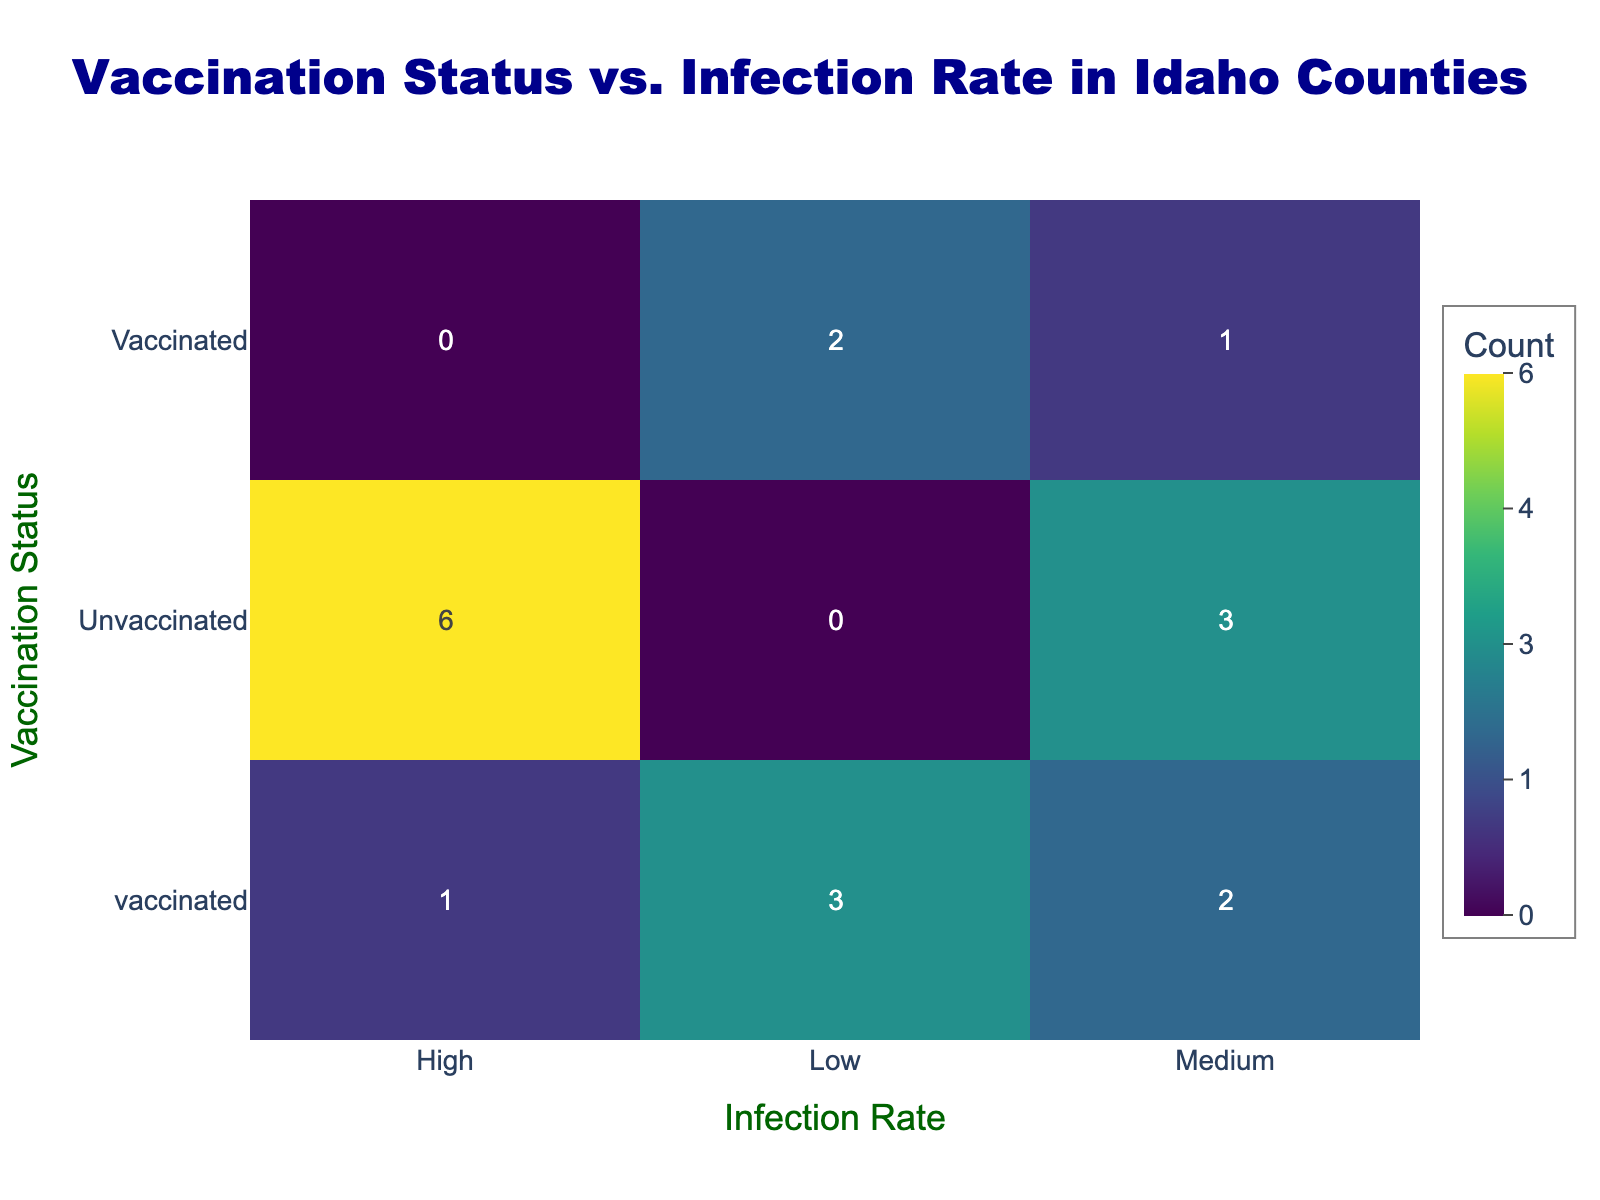What is the infection rate for vaccinated individuals in Ada County? In the table, the row for Ada County under the "Vaccinated" category shows an infection rate of "Low". Therefore, the answer is based directly on this single observation.
Answer: Low How many counties have vaccinated individuals with a medium infection rate? The counties with vaccinated individuals and a medium infection rate are Canyon and Latah. Therefore, counting these entries gives us 2 counties.
Answer: 2 Is it true that Bannock County has unvaccinated individuals with a low infection rate? Looking at the data for Bannock County, the row for unvaccinated individuals shows an infection rate of "High", so this statement is false.
Answer: No What is the total count of unvaccinated individuals across all counties represented in the table? To find the total, we count the unvaccinated entries: Ada (1), Canyon (1), Bonner (1), Bannock (1), Bingham (1), Kootenai (1), Latah (1), Twin Falls (1), and Idaho (1). This gives us a sum of 8 unvaccinated individuals.
Answer: 8 Among the counties listed, which has the highest infection rate for unvaccinated individuals? The table shows that Bannock and Kootenai counties both report "High" infection rates for unvaccinated individuals, which is the highest listed.
Answer: Bannock and Kootenai How does the infection rate for vaccinated individuals compare to that of unvaccinated individuals in the same counties? By examining the data, vaccinated individuals have either "Low" or "Medium" infection rates, while unvaccinated individuals predominantly have "High" infection rates, showing a significant difference in infection rates.
Answer: Vaccinated have lower rates than unvaccinated In which county are both vaccinated and unvaccinated individuals reported to have a medium infection rate? Looking at the table, Canyon County is the only county where vaccinated individuals have a medium infection rate, while unvaccinated individuals also have "High". Therefore, this county stands out uniquely for this characteristic.
Answer: Canyon County What percentage of counties have vaccinated individuals with low infection rates? There are a total of 8 counties, with 4 of them (Ada, Bonner, Bingham, Kootenai, Idaho) showing "Low" infection rates for vaccinated individuals. Therefore, the percentage is (4/8)*100 = 50%.
Answer: 50% What is the overall trend regarding vaccination status and infection rates across the counties? The general trend indicates that vaccinated individuals tend to have lower infection rates compared to unvaccinated individuals, based on the observed data in this table.
Answer: Vaccinated have lower rates 